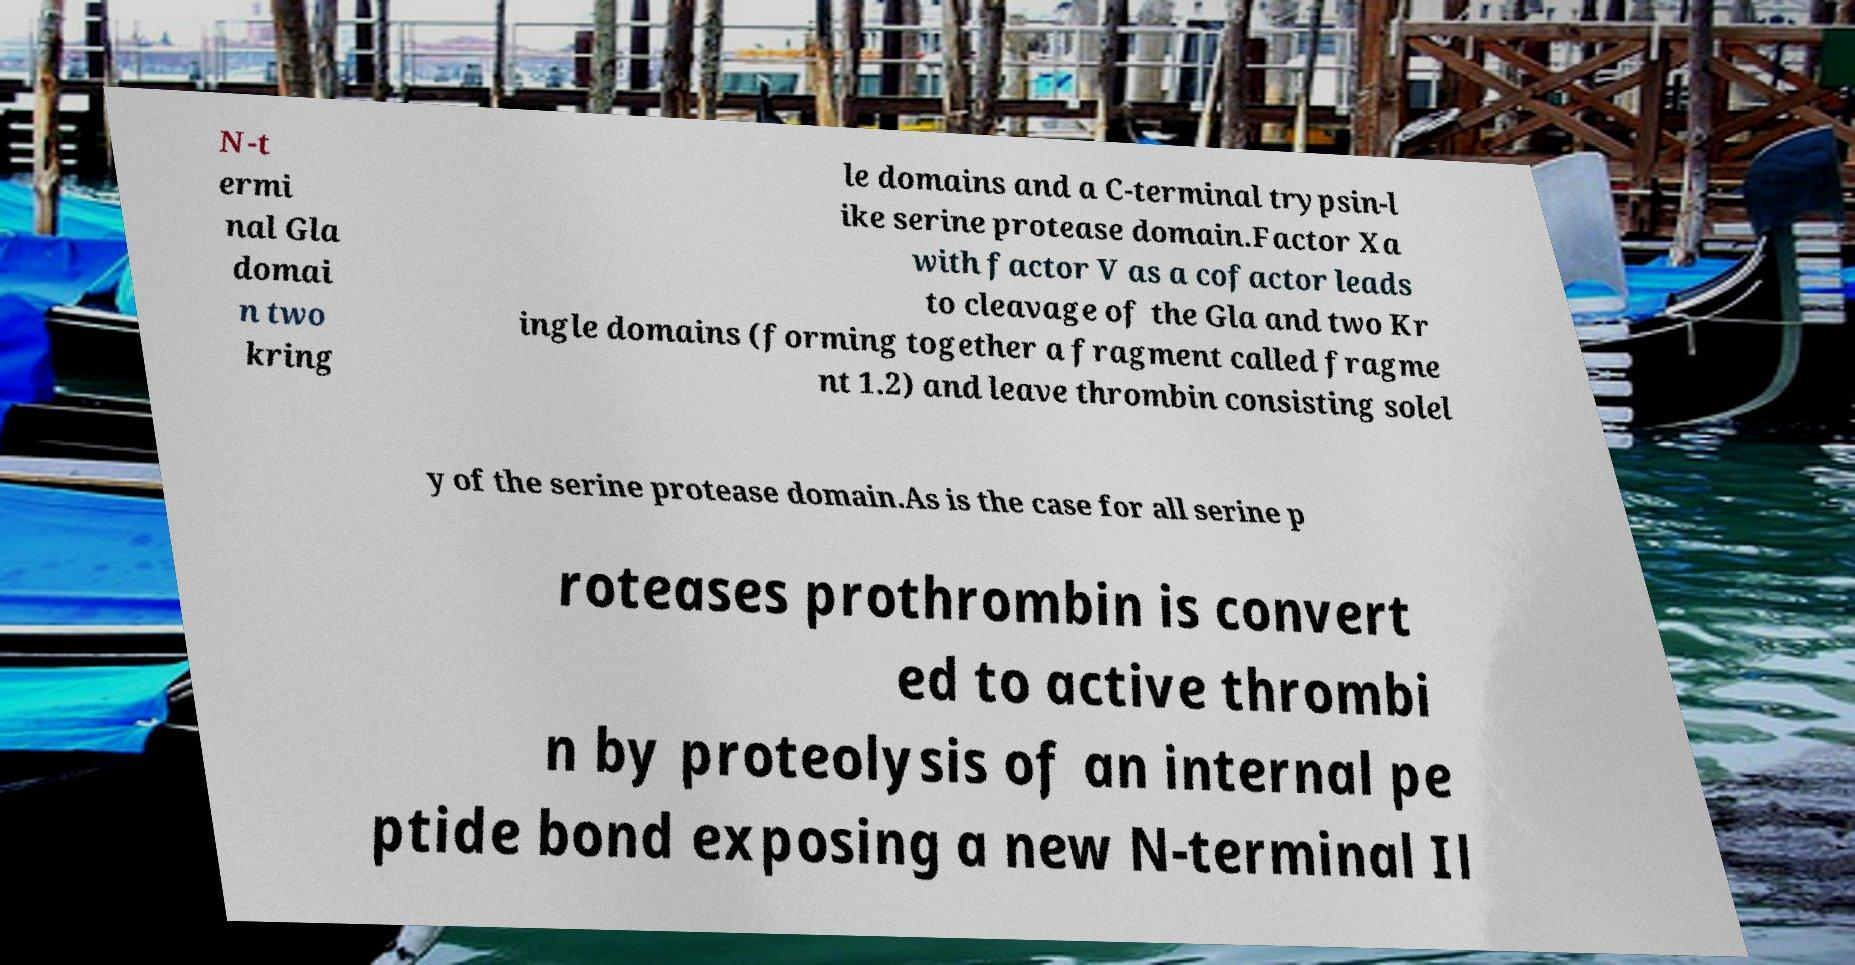There's text embedded in this image that I need extracted. Can you transcribe it verbatim? N-t ermi nal Gla domai n two kring le domains and a C-terminal trypsin-l ike serine protease domain.Factor Xa with factor V as a cofactor leads to cleavage of the Gla and two Kr ingle domains (forming together a fragment called fragme nt 1.2) and leave thrombin consisting solel y of the serine protease domain.As is the case for all serine p roteases prothrombin is convert ed to active thrombi n by proteolysis of an internal pe ptide bond exposing a new N-terminal Il 